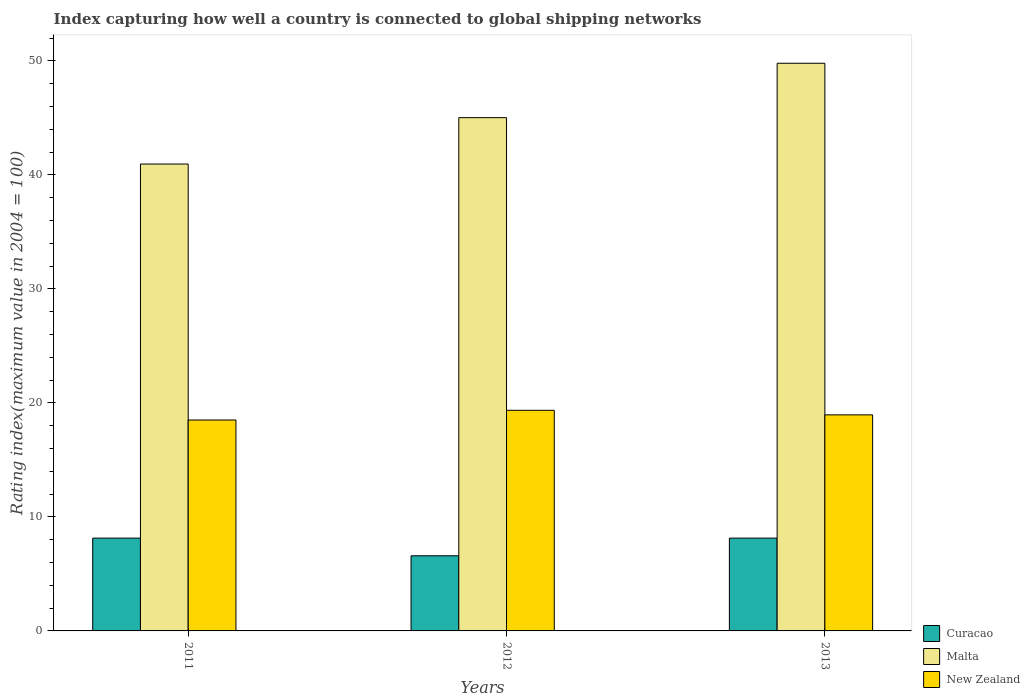How many groups of bars are there?
Keep it short and to the point. 3. How many bars are there on the 2nd tick from the left?
Provide a succinct answer. 3. How many bars are there on the 3rd tick from the right?
Ensure brevity in your answer.  3. In how many cases, is the number of bars for a given year not equal to the number of legend labels?
Provide a succinct answer. 0. What is the rating index in Malta in 2012?
Ensure brevity in your answer.  45.02. Across all years, what is the maximum rating index in Curacao?
Ensure brevity in your answer.  8.14. In which year was the rating index in Malta minimum?
Give a very brief answer. 2011. What is the total rating index in Malta in the graph?
Give a very brief answer. 135.76. What is the difference between the rating index in Curacao in 2011 and that in 2012?
Offer a very short reply. 1.55. What is the difference between the rating index in Curacao in 2011 and the rating index in Malta in 2013?
Provide a short and direct response. -41.65. What is the average rating index in Malta per year?
Offer a terse response. 45.25. In the year 2011, what is the difference between the rating index in Curacao and rating index in Malta?
Make the answer very short. -32.81. In how many years, is the rating index in Malta greater than 32?
Give a very brief answer. 3. What is the ratio of the rating index in New Zealand in 2011 to that in 2012?
Your response must be concise. 0.96. Is the difference between the rating index in Curacao in 2011 and 2013 greater than the difference between the rating index in Malta in 2011 and 2013?
Offer a very short reply. Yes. What is the difference between the highest and the second highest rating index in New Zealand?
Offer a very short reply. 0.4. What is the difference between the highest and the lowest rating index in Malta?
Keep it short and to the point. 8.84. What does the 2nd bar from the left in 2012 represents?
Keep it short and to the point. Malta. What does the 1st bar from the right in 2013 represents?
Your answer should be compact. New Zealand. Are all the bars in the graph horizontal?
Provide a short and direct response. No. What is the difference between two consecutive major ticks on the Y-axis?
Offer a terse response. 10. Are the values on the major ticks of Y-axis written in scientific E-notation?
Make the answer very short. No. Does the graph contain any zero values?
Provide a succinct answer. No. Does the graph contain grids?
Offer a very short reply. No. Where does the legend appear in the graph?
Offer a terse response. Bottom right. How many legend labels are there?
Keep it short and to the point. 3. What is the title of the graph?
Ensure brevity in your answer.  Index capturing how well a country is connected to global shipping networks. What is the label or title of the X-axis?
Offer a terse response. Years. What is the label or title of the Y-axis?
Provide a succinct answer. Rating index(maximum value in 2004 = 100). What is the Rating index(maximum value in 2004 = 100) in Curacao in 2011?
Give a very brief answer. 8.14. What is the Rating index(maximum value in 2004 = 100) of Malta in 2011?
Give a very brief answer. 40.95. What is the Rating index(maximum value in 2004 = 100) in New Zealand in 2011?
Offer a very short reply. 18.5. What is the Rating index(maximum value in 2004 = 100) in Curacao in 2012?
Your answer should be very brief. 6.59. What is the Rating index(maximum value in 2004 = 100) of Malta in 2012?
Your response must be concise. 45.02. What is the Rating index(maximum value in 2004 = 100) of New Zealand in 2012?
Provide a short and direct response. 19.35. What is the Rating index(maximum value in 2004 = 100) of Curacao in 2013?
Provide a succinct answer. 8.14. What is the Rating index(maximum value in 2004 = 100) of Malta in 2013?
Offer a very short reply. 49.79. What is the Rating index(maximum value in 2004 = 100) in New Zealand in 2013?
Make the answer very short. 18.95. Across all years, what is the maximum Rating index(maximum value in 2004 = 100) of Curacao?
Give a very brief answer. 8.14. Across all years, what is the maximum Rating index(maximum value in 2004 = 100) in Malta?
Keep it short and to the point. 49.79. Across all years, what is the maximum Rating index(maximum value in 2004 = 100) of New Zealand?
Make the answer very short. 19.35. Across all years, what is the minimum Rating index(maximum value in 2004 = 100) in Curacao?
Provide a succinct answer. 6.59. Across all years, what is the minimum Rating index(maximum value in 2004 = 100) of Malta?
Offer a very short reply. 40.95. Across all years, what is the minimum Rating index(maximum value in 2004 = 100) of New Zealand?
Your response must be concise. 18.5. What is the total Rating index(maximum value in 2004 = 100) of Curacao in the graph?
Keep it short and to the point. 22.87. What is the total Rating index(maximum value in 2004 = 100) in Malta in the graph?
Offer a terse response. 135.76. What is the total Rating index(maximum value in 2004 = 100) in New Zealand in the graph?
Provide a short and direct response. 56.8. What is the difference between the Rating index(maximum value in 2004 = 100) in Curacao in 2011 and that in 2012?
Provide a succinct answer. 1.55. What is the difference between the Rating index(maximum value in 2004 = 100) in Malta in 2011 and that in 2012?
Give a very brief answer. -4.07. What is the difference between the Rating index(maximum value in 2004 = 100) of New Zealand in 2011 and that in 2012?
Give a very brief answer. -0.85. What is the difference between the Rating index(maximum value in 2004 = 100) in Curacao in 2011 and that in 2013?
Make the answer very short. 0. What is the difference between the Rating index(maximum value in 2004 = 100) of Malta in 2011 and that in 2013?
Offer a terse response. -8.84. What is the difference between the Rating index(maximum value in 2004 = 100) of New Zealand in 2011 and that in 2013?
Provide a succinct answer. -0.45. What is the difference between the Rating index(maximum value in 2004 = 100) in Curacao in 2012 and that in 2013?
Make the answer very short. -1.55. What is the difference between the Rating index(maximum value in 2004 = 100) of Malta in 2012 and that in 2013?
Provide a short and direct response. -4.77. What is the difference between the Rating index(maximum value in 2004 = 100) of Curacao in 2011 and the Rating index(maximum value in 2004 = 100) of Malta in 2012?
Provide a short and direct response. -36.88. What is the difference between the Rating index(maximum value in 2004 = 100) of Curacao in 2011 and the Rating index(maximum value in 2004 = 100) of New Zealand in 2012?
Your answer should be very brief. -11.21. What is the difference between the Rating index(maximum value in 2004 = 100) in Malta in 2011 and the Rating index(maximum value in 2004 = 100) in New Zealand in 2012?
Your answer should be compact. 21.6. What is the difference between the Rating index(maximum value in 2004 = 100) in Curacao in 2011 and the Rating index(maximum value in 2004 = 100) in Malta in 2013?
Keep it short and to the point. -41.65. What is the difference between the Rating index(maximum value in 2004 = 100) in Curacao in 2011 and the Rating index(maximum value in 2004 = 100) in New Zealand in 2013?
Offer a very short reply. -10.81. What is the difference between the Rating index(maximum value in 2004 = 100) of Malta in 2011 and the Rating index(maximum value in 2004 = 100) of New Zealand in 2013?
Your response must be concise. 22. What is the difference between the Rating index(maximum value in 2004 = 100) in Curacao in 2012 and the Rating index(maximum value in 2004 = 100) in Malta in 2013?
Your answer should be compact. -43.2. What is the difference between the Rating index(maximum value in 2004 = 100) in Curacao in 2012 and the Rating index(maximum value in 2004 = 100) in New Zealand in 2013?
Offer a very short reply. -12.36. What is the difference between the Rating index(maximum value in 2004 = 100) in Malta in 2012 and the Rating index(maximum value in 2004 = 100) in New Zealand in 2013?
Provide a succinct answer. 26.07. What is the average Rating index(maximum value in 2004 = 100) of Curacao per year?
Offer a terse response. 7.62. What is the average Rating index(maximum value in 2004 = 100) of Malta per year?
Offer a terse response. 45.25. What is the average Rating index(maximum value in 2004 = 100) of New Zealand per year?
Your response must be concise. 18.93. In the year 2011, what is the difference between the Rating index(maximum value in 2004 = 100) in Curacao and Rating index(maximum value in 2004 = 100) in Malta?
Your answer should be very brief. -32.81. In the year 2011, what is the difference between the Rating index(maximum value in 2004 = 100) in Curacao and Rating index(maximum value in 2004 = 100) in New Zealand?
Ensure brevity in your answer.  -10.36. In the year 2011, what is the difference between the Rating index(maximum value in 2004 = 100) of Malta and Rating index(maximum value in 2004 = 100) of New Zealand?
Offer a very short reply. 22.45. In the year 2012, what is the difference between the Rating index(maximum value in 2004 = 100) of Curacao and Rating index(maximum value in 2004 = 100) of Malta?
Your answer should be very brief. -38.43. In the year 2012, what is the difference between the Rating index(maximum value in 2004 = 100) in Curacao and Rating index(maximum value in 2004 = 100) in New Zealand?
Your answer should be very brief. -12.76. In the year 2012, what is the difference between the Rating index(maximum value in 2004 = 100) in Malta and Rating index(maximum value in 2004 = 100) in New Zealand?
Provide a short and direct response. 25.67. In the year 2013, what is the difference between the Rating index(maximum value in 2004 = 100) of Curacao and Rating index(maximum value in 2004 = 100) of Malta?
Your answer should be very brief. -41.65. In the year 2013, what is the difference between the Rating index(maximum value in 2004 = 100) in Curacao and Rating index(maximum value in 2004 = 100) in New Zealand?
Your answer should be very brief. -10.81. In the year 2013, what is the difference between the Rating index(maximum value in 2004 = 100) in Malta and Rating index(maximum value in 2004 = 100) in New Zealand?
Make the answer very short. 30.84. What is the ratio of the Rating index(maximum value in 2004 = 100) in Curacao in 2011 to that in 2012?
Your answer should be compact. 1.24. What is the ratio of the Rating index(maximum value in 2004 = 100) of Malta in 2011 to that in 2012?
Your answer should be compact. 0.91. What is the ratio of the Rating index(maximum value in 2004 = 100) in New Zealand in 2011 to that in 2012?
Provide a succinct answer. 0.96. What is the ratio of the Rating index(maximum value in 2004 = 100) of Curacao in 2011 to that in 2013?
Your answer should be compact. 1. What is the ratio of the Rating index(maximum value in 2004 = 100) of Malta in 2011 to that in 2013?
Your answer should be very brief. 0.82. What is the ratio of the Rating index(maximum value in 2004 = 100) in New Zealand in 2011 to that in 2013?
Keep it short and to the point. 0.98. What is the ratio of the Rating index(maximum value in 2004 = 100) of Curacao in 2012 to that in 2013?
Offer a very short reply. 0.81. What is the ratio of the Rating index(maximum value in 2004 = 100) in Malta in 2012 to that in 2013?
Ensure brevity in your answer.  0.9. What is the ratio of the Rating index(maximum value in 2004 = 100) of New Zealand in 2012 to that in 2013?
Make the answer very short. 1.02. What is the difference between the highest and the second highest Rating index(maximum value in 2004 = 100) in Curacao?
Your answer should be compact. 0. What is the difference between the highest and the second highest Rating index(maximum value in 2004 = 100) of Malta?
Provide a succinct answer. 4.77. What is the difference between the highest and the lowest Rating index(maximum value in 2004 = 100) of Curacao?
Offer a very short reply. 1.55. What is the difference between the highest and the lowest Rating index(maximum value in 2004 = 100) of Malta?
Make the answer very short. 8.84. What is the difference between the highest and the lowest Rating index(maximum value in 2004 = 100) of New Zealand?
Make the answer very short. 0.85. 